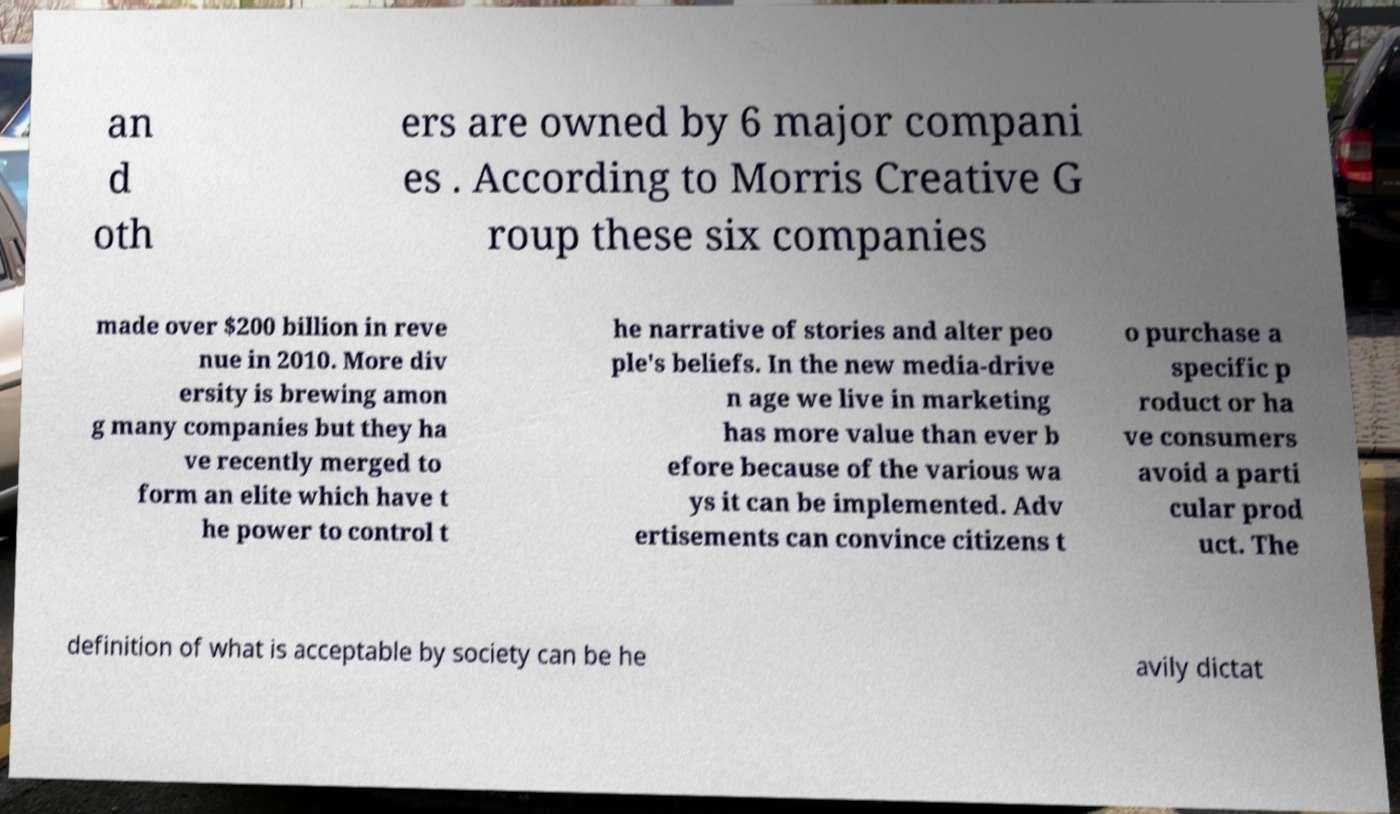Could you assist in decoding the text presented in this image and type it out clearly? an d oth ers are owned by 6 major compani es . According to Morris Creative G roup these six companies made over $200 billion in reve nue in 2010. More div ersity is brewing amon g many companies but they ha ve recently merged to form an elite which have t he power to control t he narrative of stories and alter peo ple's beliefs. In the new media-drive n age we live in marketing has more value than ever b efore because of the various wa ys it can be implemented. Adv ertisements can convince citizens t o purchase a specific p roduct or ha ve consumers avoid a parti cular prod uct. The definition of what is acceptable by society can be he avily dictat 